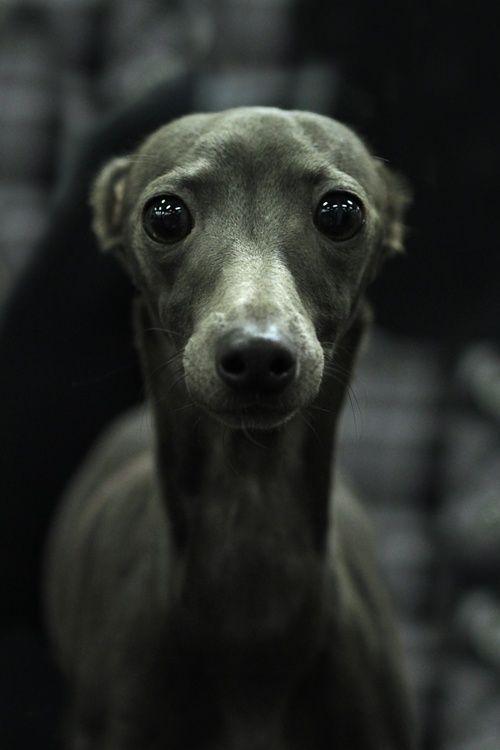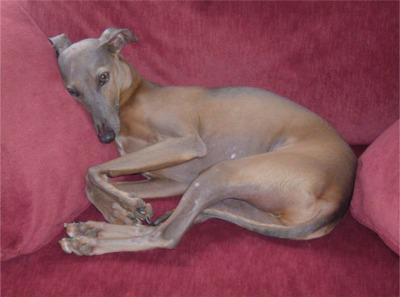The first image is the image on the left, the second image is the image on the right. Assess this claim about the two images: "An image shows a two-color dog sitting upright with its eyes on the camera.". Correct or not? Answer yes or no. No. The first image is the image on the left, the second image is the image on the right. Considering the images on both sides, is "Exactly one of the dogs is lying down." valid? Answer yes or no. Yes. 